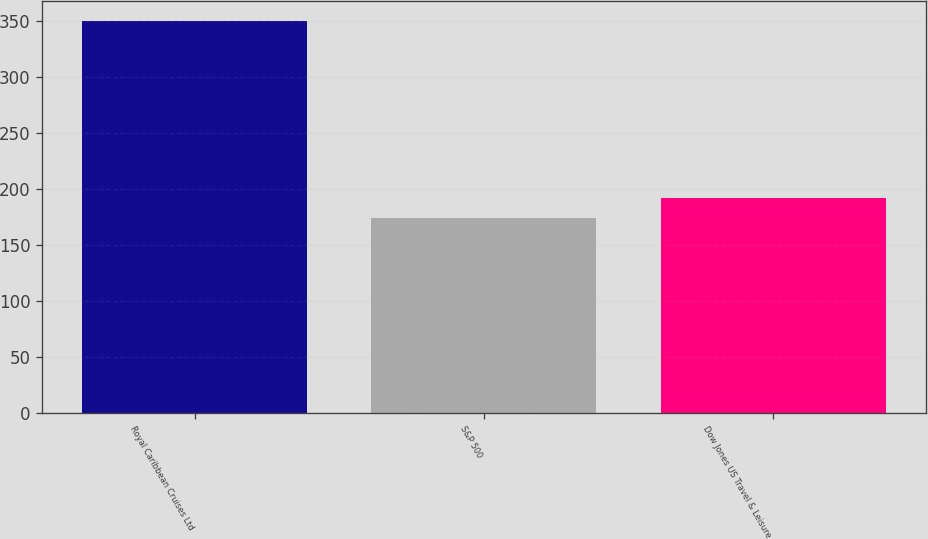Convert chart. <chart><loc_0><loc_0><loc_500><loc_500><bar_chart><fcel>Royal Caribbean Cruises Ltd<fcel>S&P 500<fcel>Dow Jones US Travel & Leisure<nl><fcel>350.4<fcel>174.6<fcel>192.18<nl></chart> 